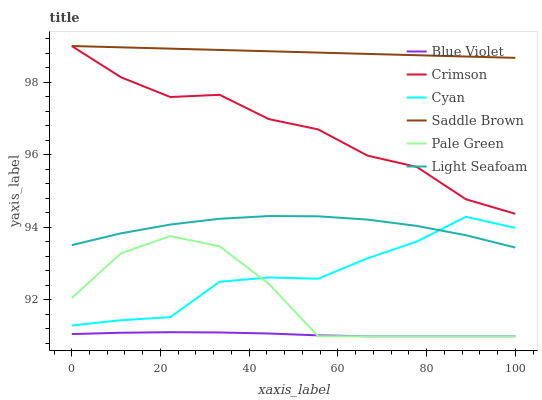Does Blue Violet have the minimum area under the curve?
Answer yes or no. Yes. Does Saddle Brown have the maximum area under the curve?
Answer yes or no. Yes. Does Crimson have the minimum area under the curve?
Answer yes or no. No. Does Crimson have the maximum area under the curve?
Answer yes or no. No. Is Saddle Brown the smoothest?
Answer yes or no. Yes. Is Pale Green the roughest?
Answer yes or no. Yes. Is Crimson the smoothest?
Answer yes or no. No. Is Crimson the roughest?
Answer yes or no. No. Does Pale Green have the lowest value?
Answer yes or no. Yes. Does Crimson have the lowest value?
Answer yes or no. No. Does Saddle Brown have the highest value?
Answer yes or no. Yes. Does Cyan have the highest value?
Answer yes or no. No. Is Pale Green less than Crimson?
Answer yes or no. Yes. Is Light Seafoam greater than Blue Violet?
Answer yes or no. Yes. Does Crimson intersect Saddle Brown?
Answer yes or no. Yes. Is Crimson less than Saddle Brown?
Answer yes or no. No. Is Crimson greater than Saddle Brown?
Answer yes or no. No. Does Pale Green intersect Crimson?
Answer yes or no. No. 